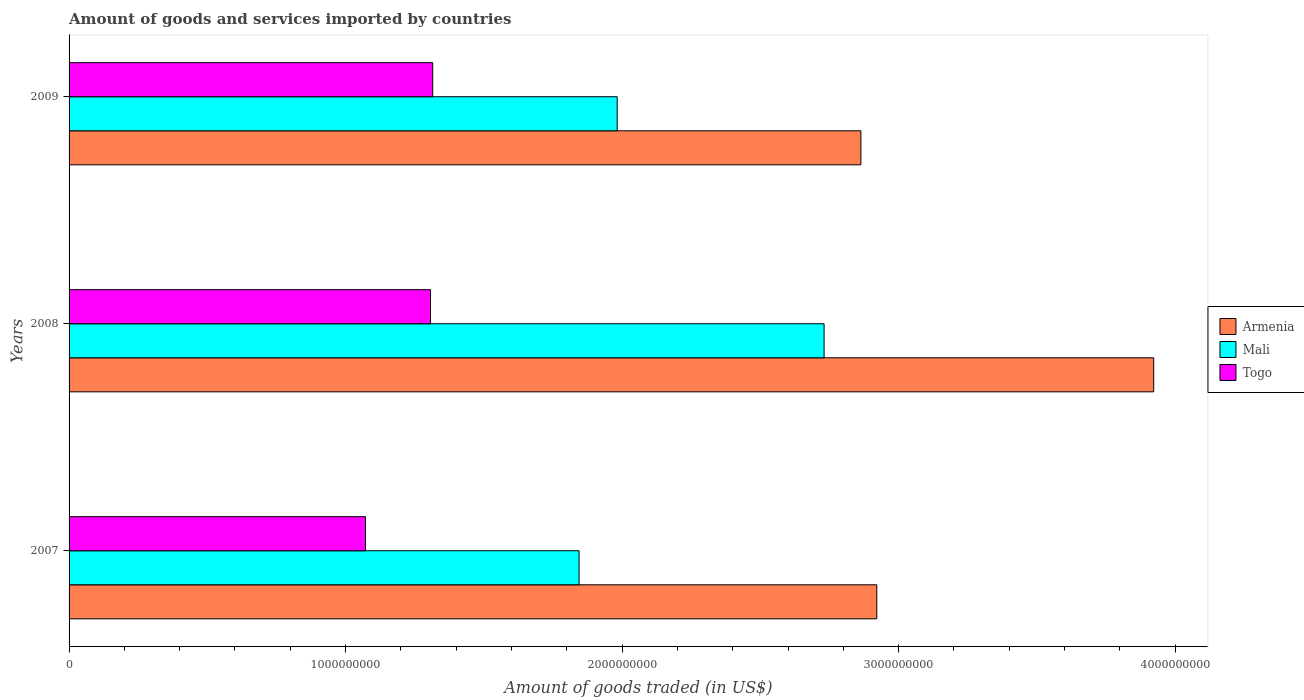How many different coloured bars are there?
Give a very brief answer. 3. Are the number of bars per tick equal to the number of legend labels?
Offer a very short reply. Yes. Are the number of bars on each tick of the Y-axis equal?
Make the answer very short. Yes. How many bars are there on the 2nd tick from the top?
Your response must be concise. 3. How many bars are there on the 2nd tick from the bottom?
Make the answer very short. 3. What is the label of the 1st group of bars from the top?
Ensure brevity in your answer.  2009. What is the total amount of goods and services imported in Armenia in 2008?
Your response must be concise. 3.92e+09. Across all years, what is the maximum total amount of goods and services imported in Mali?
Provide a short and direct response. 2.73e+09. Across all years, what is the minimum total amount of goods and services imported in Togo?
Ensure brevity in your answer.  1.07e+09. What is the total total amount of goods and services imported in Togo in the graph?
Provide a succinct answer. 3.69e+09. What is the difference between the total amount of goods and services imported in Armenia in 2007 and that in 2008?
Provide a short and direct response. -1.00e+09. What is the difference between the total amount of goods and services imported in Togo in 2008 and the total amount of goods and services imported in Mali in 2007?
Your answer should be very brief. -5.37e+08. What is the average total amount of goods and services imported in Armenia per year?
Provide a short and direct response. 3.24e+09. In the year 2009, what is the difference between the total amount of goods and services imported in Armenia and total amount of goods and services imported in Mali?
Keep it short and to the point. 8.81e+08. In how many years, is the total amount of goods and services imported in Armenia greater than 3600000000 US$?
Make the answer very short. 1. What is the ratio of the total amount of goods and services imported in Togo in 2007 to that in 2008?
Your answer should be very brief. 0.82. Is the total amount of goods and services imported in Mali in 2008 less than that in 2009?
Offer a very short reply. No. What is the difference between the highest and the second highest total amount of goods and services imported in Mali?
Make the answer very short. 7.48e+08. What is the difference between the highest and the lowest total amount of goods and services imported in Togo?
Provide a succinct answer. 2.43e+08. In how many years, is the total amount of goods and services imported in Armenia greater than the average total amount of goods and services imported in Armenia taken over all years?
Make the answer very short. 1. Is the sum of the total amount of goods and services imported in Mali in 2007 and 2008 greater than the maximum total amount of goods and services imported in Togo across all years?
Provide a succinct answer. Yes. What does the 3rd bar from the top in 2009 represents?
Your answer should be compact. Armenia. What does the 2nd bar from the bottom in 2007 represents?
Provide a short and direct response. Mali. Is it the case that in every year, the sum of the total amount of goods and services imported in Armenia and total amount of goods and services imported in Togo is greater than the total amount of goods and services imported in Mali?
Offer a terse response. Yes. Are all the bars in the graph horizontal?
Give a very brief answer. Yes. What is the difference between two consecutive major ticks on the X-axis?
Offer a very short reply. 1.00e+09. Are the values on the major ticks of X-axis written in scientific E-notation?
Offer a terse response. No. Does the graph contain any zero values?
Your response must be concise. No. Does the graph contain grids?
Ensure brevity in your answer.  No. How many legend labels are there?
Provide a short and direct response. 3. How are the legend labels stacked?
Make the answer very short. Vertical. What is the title of the graph?
Offer a terse response. Amount of goods and services imported by countries. Does "Djibouti" appear as one of the legend labels in the graph?
Your answer should be compact. No. What is the label or title of the X-axis?
Give a very brief answer. Amount of goods traded (in US$). What is the label or title of the Y-axis?
Keep it short and to the point. Years. What is the Amount of goods traded (in US$) in Armenia in 2007?
Ensure brevity in your answer.  2.92e+09. What is the Amount of goods traded (in US$) in Mali in 2007?
Ensure brevity in your answer.  1.84e+09. What is the Amount of goods traded (in US$) in Togo in 2007?
Offer a very short reply. 1.07e+09. What is the Amount of goods traded (in US$) of Armenia in 2008?
Make the answer very short. 3.92e+09. What is the Amount of goods traded (in US$) in Mali in 2008?
Give a very brief answer. 2.73e+09. What is the Amount of goods traded (in US$) of Togo in 2008?
Provide a short and direct response. 1.31e+09. What is the Amount of goods traded (in US$) in Armenia in 2009?
Ensure brevity in your answer.  2.86e+09. What is the Amount of goods traded (in US$) of Mali in 2009?
Your answer should be compact. 1.98e+09. What is the Amount of goods traded (in US$) in Togo in 2009?
Your response must be concise. 1.32e+09. Across all years, what is the maximum Amount of goods traded (in US$) of Armenia?
Offer a very short reply. 3.92e+09. Across all years, what is the maximum Amount of goods traded (in US$) in Mali?
Your answer should be compact. 2.73e+09. Across all years, what is the maximum Amount of goods traded (in US$) in Togo?
Offer a very short reply. 1.32e+09. Across all years, what is the minimum Amount of goods traded (in US$) of Armenia?
Provide a short and direct response. 2.86e+09. Across all years, what is the minimum Amount of goods traded (in US$) in Mali?
Ensure brevity in your answer.  1.84e+09. Across all years, what is the minimum Amount of goods traded (in US$) of Togo?
Offer a very short reply. 1.07e+09. What is the total Amount of goods traded (in US$) of Armenia in the graph?
Your response must be concise. 9.71e+09. What is the total Amount of goods traded (in US$) of Mali in the graph?
Give a very brief answer. 6.56e+09. What is the total Amount of goods traded (in US$) in Togo in the graph?
Ensure brevity in your answer.  3.69e+09. What is the difference between the Amount of goods traded (in US$) in Armenia in 2007 and that in 2008?
Provide a short and direct response. -1.00e+09. What is the difference between the Amount of goods traded (in US$) in Mali in 2007 and that in 2008?
Ensure brevity in your answer.  -8.86e+08. What is the difference between the Amount of goods traded (in US$) of Togo in 2007 and that in 2008?
Provide a short and direct response. -2.35e+08. What is the difference between the Amount of goods traded (in US$) of Armenia in 2007 and that in 2009?
Offer a terse response. 5.75e+07. What is the difference between the Amount of goods traded (in US$) in Mali in 2007 and that in 2009?
Provide a short and direct response. -1.38e+08. What is the difference between the Amount of goods traded (in US$) of Togo in 2007 and that in 2009?
Provide a succinct answer. -2.43e+08. What is the difference between the Amount of goods traded (in US$) in Armenia in 2008 and that in 2009?
Keep it short and to the point. 1.06e+09. What is the difference between the Amount of goods traded (in US$) of Mali in 2008 and that in 2009?
Your answer should be compact. 7.48e+08. What is the difference between the Amount of goods traded (in US$) in Togo in 2008 and that in 2009?
Ensure brevity in your answer.  -7.92e+06. What is the difference between the Amount of goods traded (in US$) of Armenia in 2007 and the Amount of goods traded (in US$) of Mali in 2008?
Offer a very short reply. 1.91e+08. What is the difference between the Amount of goods traded (in US$) of Armenia in 2007 and the Amount of goods traded (in US$) of Togo in 2008?
Keep it short and to the point. 1.61e+09. What is the difference between the Amount of goods traded (in US$) of Mali in 2007 and the Amount of goods traded (in US$) of Togo in 2008?
Ensure brevity in your answer.  5.37e+08. What is the difference between the Amount of goods traded (in US$) in Armenia in 2007 and the Amount of goods traded (in US$) in Mali in 2009?
Provide a succinct answer. 9.39e+08. What is the difference between the Amount of goods traded (in US$) in Armenia in 2007 and the Amount of goods traded (in US$) in Togo in 2009?
Give a very brief answer. 1.61e+09. What is the difference between the Amount of goods traded (in US$) of Mali in 2007 and the Amount of goods traded (in US$) of Togo in 2009?
Your response must be concise. 5.29e+08. What is the difference between the Amount of goods traded (in US$) of Armenia in 2008 and the Amount of goods traded (in US$) of Mali in 2009?
Offer a terse response. 1.94e+09. What is the difference between the Amount of goods traded (in US$) in Armenia in 2008 and the Amount of goods traded (in US$) in Togo in 2009?
Your answer should be compact. 2.61e+09. What is the difference between the Amount of goods traded (in US$) of Mali in 2008 and the Amount of goods traded (in US$) of Togo in 2009?
Your response must be concise. 1.42e+09. What is the average Amount of goods traded (in US$) of Armenia per year?
Your response must be concise. 3.24e+09. What is the average Amount of goods traded (in US$) of Mali per year?
Ensure brevity in your answer.  2.19e+09. What is the average Amount of goods traded (in US$) in Togo per year?
Provide a succinct answer. 1.23e+09. In the year 2007, what is the difference between the Amount of goods traded (in US$) of Armenia and Amount of goods traded (in US$) of Mali?
Your answer should be compact. 1.08e+09. In the year 2007, what is the difference between the Amount of goods traded (in US$) in Armenia and Amount of goods traded (in US$) in Togo?
Your answer should be compact. 1.85e+09. In the year 2007, what is the difference between the Amount of goods traded (in US$) of Mali and Amount of goods traded (in US$) of Togo?
Offer a terse response. 7.72e+08. In the year 2008, what is the difference between the Amount of goods traded (in US$) in Armenia and Amount of goods traded (in US$) in Mali?
Your answer should be very brief. 1.19e+09. In the year 2008, what is the difference between the Amount of goods traded (in US$) in Armenia and Amount of goods traded (in US$) in Togo?
Make the answer very short. 2.62e+09. In the year 2008, what is the difference between the Amount of goods traded (in US$) of Mali and Amount of goods traded (in US$) of Togo?
Ensure brevity in your answer.  1.42e+09. In the year 2009, what is the difference between the Amount of goods traded (in US$) of Armenia and Amount of goods traded (in US$) of Mali?
Your answer should be very brief. 8.81e+08. In the year 2009, what is the difference between the Amount of goods traded (in US$) in Armenia and Amount of goods traded (in US$) in Togo?
Your answer should be compact. 1.55e+09. In the year 2009, what is the difference between the Amount of goods traded (in US$) in Mali and Amount of goods traded (in US$) in Togo?
Make the answer very short. 6.67e+08. What is the ratio of the Amount of goods traded (in US$) in Armenia in 2007 to that in 2008?
Provide a short and direct response. 0.74. What is the ratio of the Amount of goods traded (in US$) of Mali in 2007 to that in 2008?
Provide a short and direct response. 0.68. What is the ratio of the Amount of goods traded (in US$) in Togo in 2007 to that in 2008?
Your answer should be very brief. 0.82. What is the ratio of the Amount of goods traded (in US$) of Armenia in 2007 to that in 2009?
Your response must be concise. 1.02. What is the ratio of the Amount of goods traded (in US$) in Mali in 2007 to that in 2009?
Your answer should be compact. 0.93. What is the ratio of the Amount of goods traded (in US$) of Togo in 2007 to that in 2009?
Your answer should be compact. 0.82. What is the ratio of the Amount of goods traded (in US$) of Armenia in 2008 to that in 2009?
Make the answer very short. 1.37. What is the ratio of the Amount of goods traded (in US$) of Mali in 2008 to that in 2009?
Provide a succinct answer. 1.38. What is the difference between the highest and the second highest Amount of goods traded (in US$) of Armenia?
Give a very brief answer. 1.00e+09. What is the difference between the highest and the second highest Amount of goods traded (in US$) in Mali?
Your response must be concise. 7.48e+08. What is the difference between the highest and the second highest Amount of goods traded (in US$) of Togo?
Your answer should be very brief. 7.92e+06. What is the difference between the highest and the lowest Amount of goods traded (in US$) in Armenia?
Offer a very short reply. 1.06e+09. What is the difference between the highest and the lowest Amount of goods traded (in US$) in Mali?
Your answer should be very brief. 8.86e+08. What is the difference between the highest and the lowest Amount of goods traded (in US$) in Togo?
Offer a terse response. 2.43e+08. 